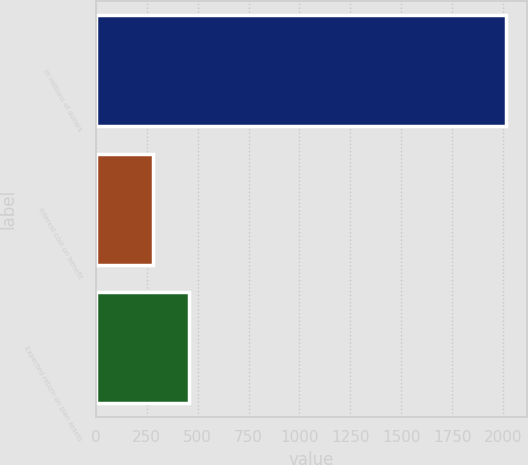Convert chart. <chart><loc_0><loc_0><loc_500><loc_500><bar_chart><fcel>In millions of dollars<fcel>Interest cost on benefit<fcel>Expected return on plan assets<nl><fcel>2016<fcel>282<fcel>455.4<nl></chart> 